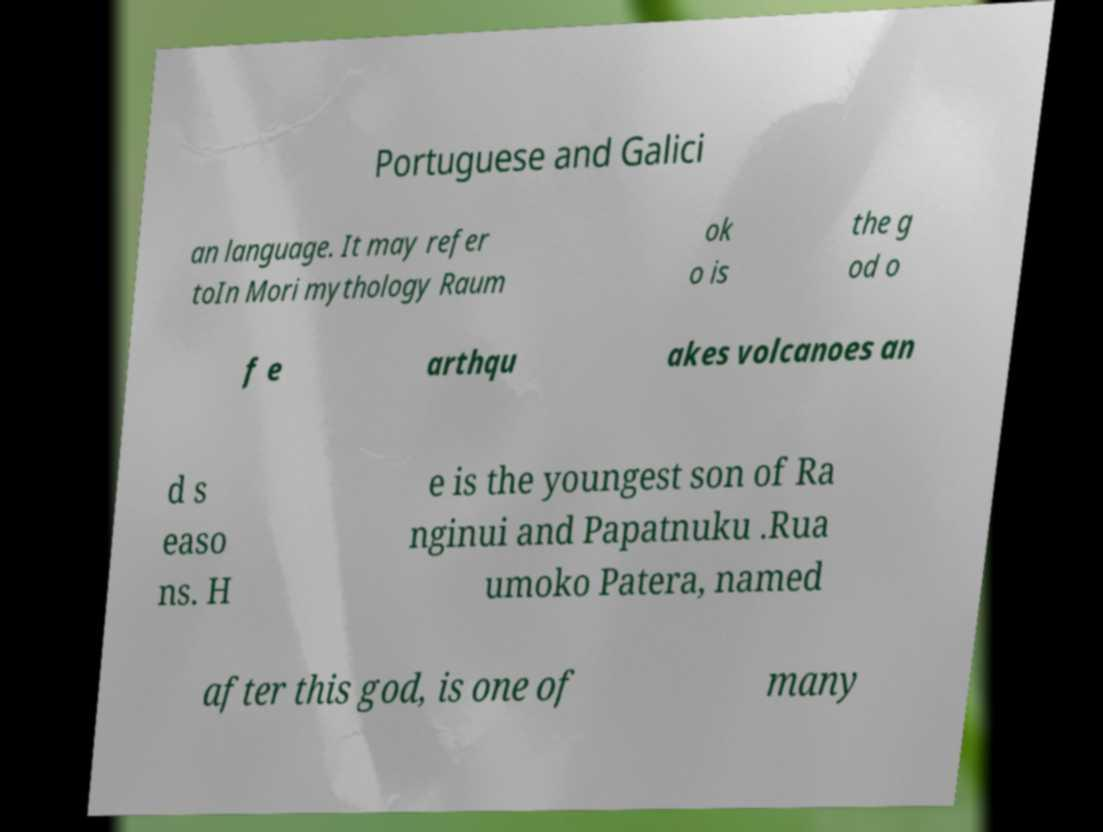Please read and relay the text visible in this image. What does it say? Portuguese and Galici an language. It may refer toIn Mori mythology Raum ok o is the g od o f e arthqu akes volcanoes an d s easo ns. H e is the youngest son of Ra nginui and Papatnuku .Rua umoko Patera, named after this god, is one of many 